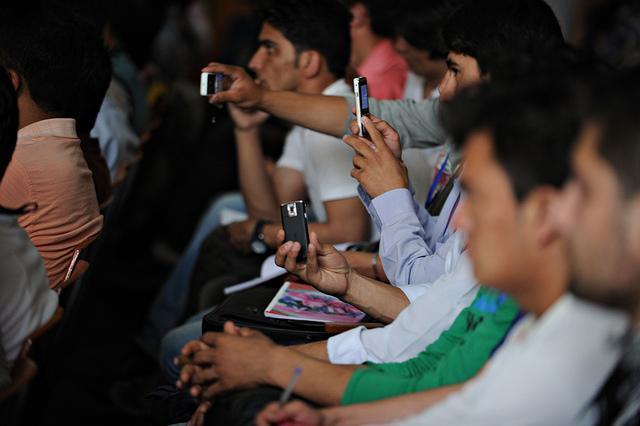How many people have cell phones?
Give a very brief answer. 3. How many people are having a conversation in the scene?
Give a very brief answer. 0. How many people are there?
Give a very brief answer. 12. 